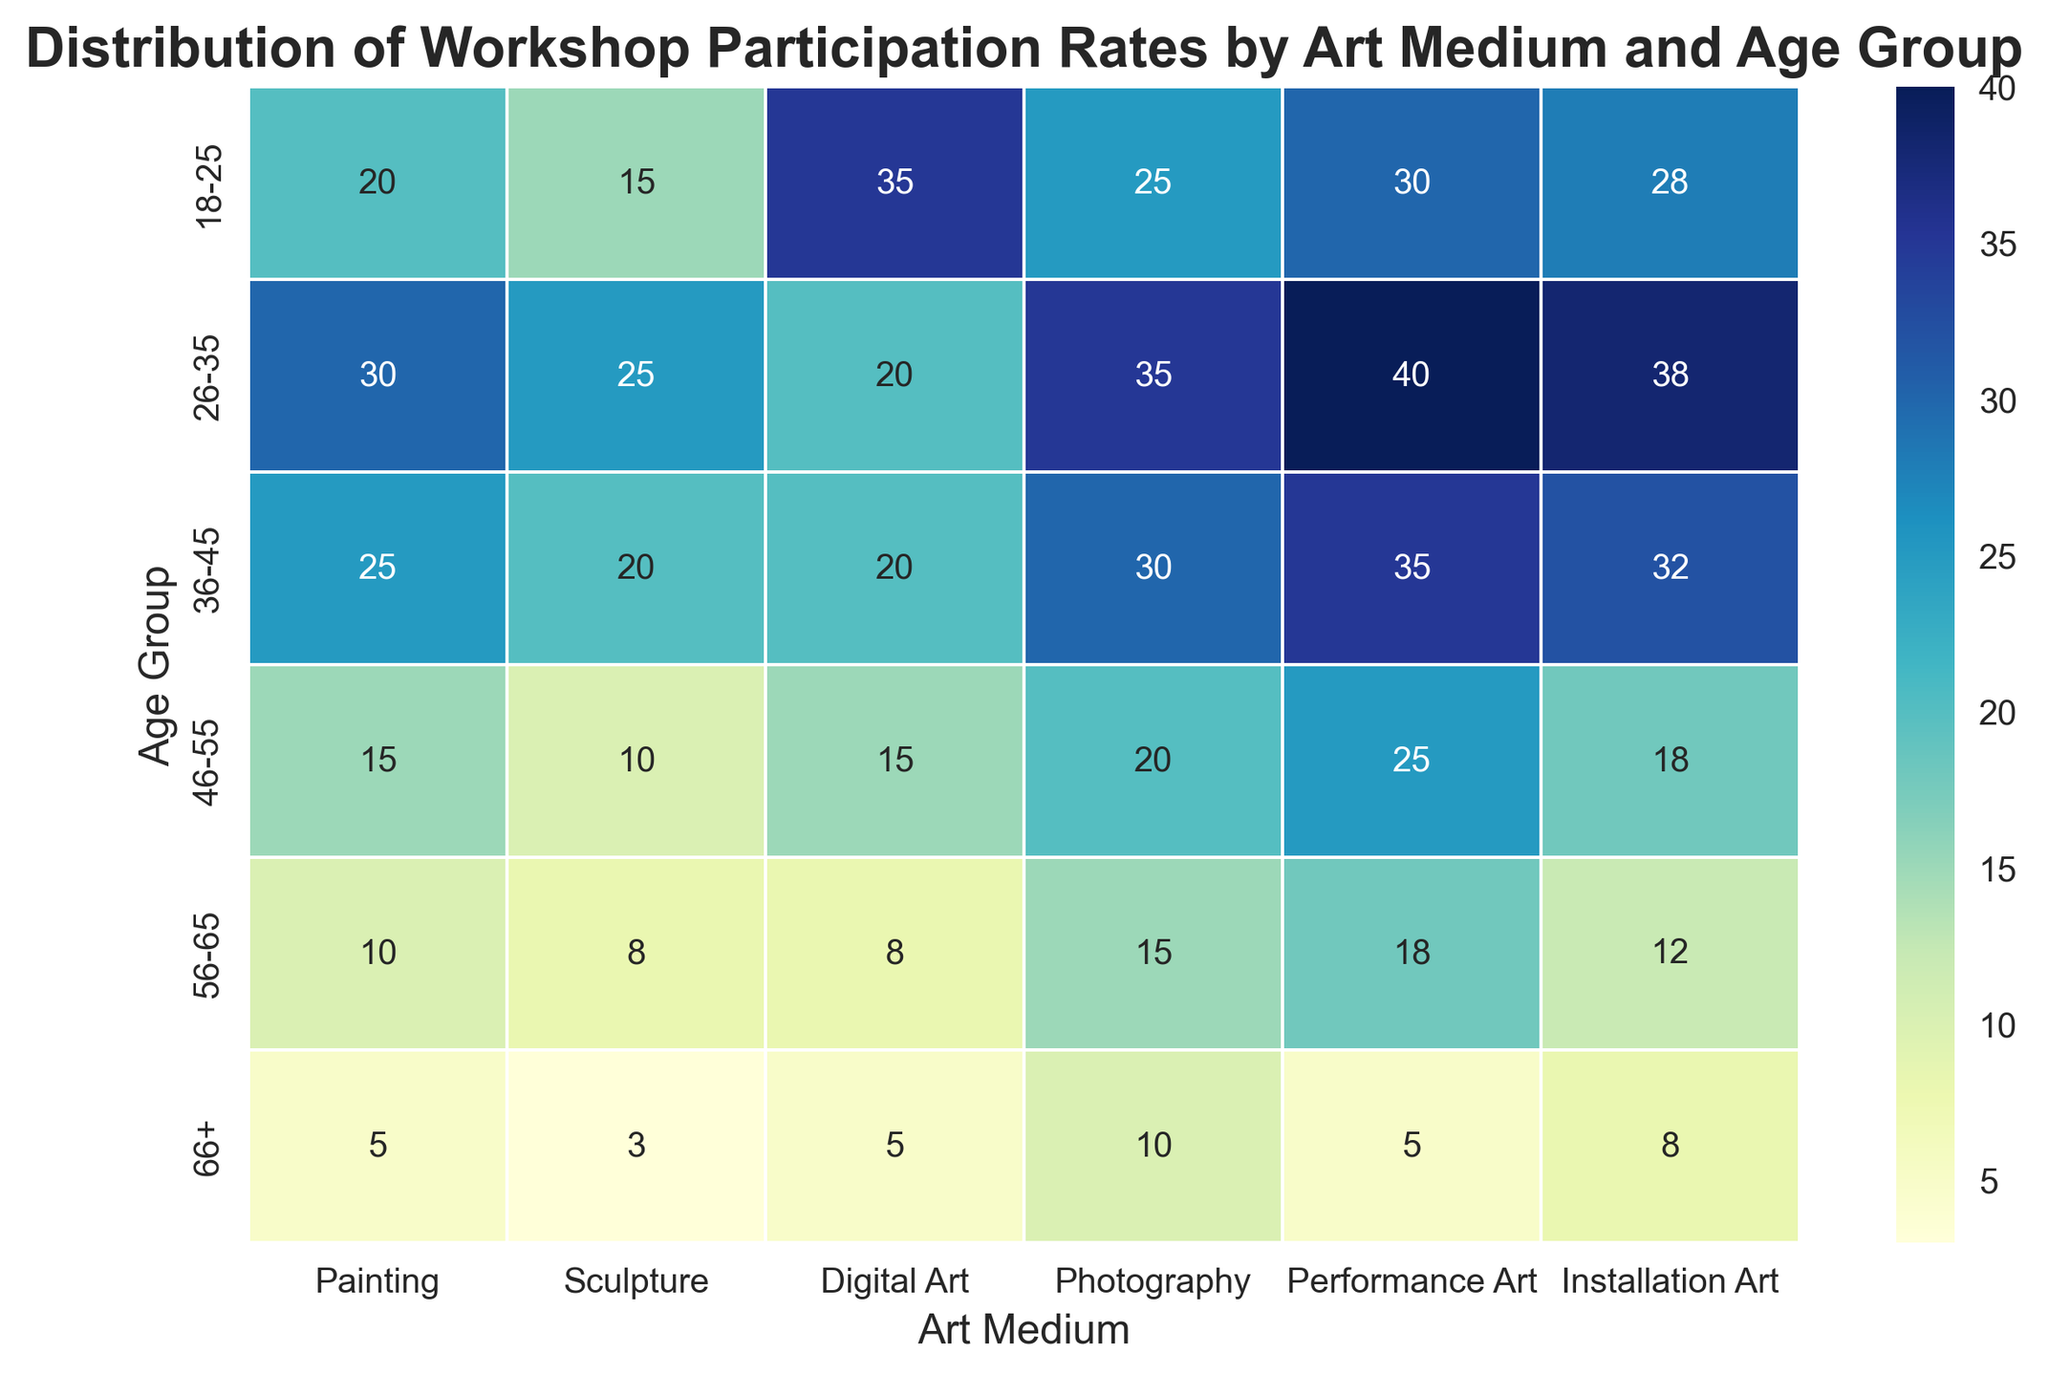Which age group has the highest participation in Digital Art workshops? Looking at the figure, the age group 18-25 has the darkest shade in the Digital Art column, indicating the highest participation rate.
Answer: 18-25 Which art medium is most popular among the 26-35 age group? From the figure, the darkest cell in the row for 26-35 age group is under Performance Art, indicating it is the most popular.
Answer: Performance Art Compare the participation rates in Installation Art workshops for the age groups 36-45 and 56-65. Which one is higher? The figure shows a darker cell for the 36-45 age group compared to the 56-65 age group in the Installation Art column, indicating a higher participation rate.
Answer: 36-45 What is the total participation rate across all art mediums for the 46-55 age group? Adding up the participation rates from the figure: 15 (Painting) + 10 (Sculpture) + 15 (Digital Art) + 20 (Photography) + 25 (Performance Art) + 18 (Installation Art) = 103.
Answer: 103 Is there an age group where Painting is not the least popular art medium? By scanning the Painting column in the figure, it has participation rates that are generally higher than Sculpture for all age groups, making Painting never the least popular.
Answer: No What is the average participation rate in Performance Art workshops across all age groups? The participation rates for Performance Art across age groups are 30, 40, 35, 25, 18, and 5. Sum: 30+40+35+25+18+5=153. Average: 153/6 = 25.5.
Answer: 25.5 Which art medium has the lowest participation rate for the 56-65 age group? From the figure, the lightest shade in the 56-65 age group row is in the Digital Art column with a rate of 8.
Answer: Digital Art Find the difference in participation rates between Photography and Performance Art workshops for the 36-45 age group. Participation rates from the figure are 30 for Photography and 35 for Performance Art. Difference: 35 - 30 = 5.
Answer: 5 